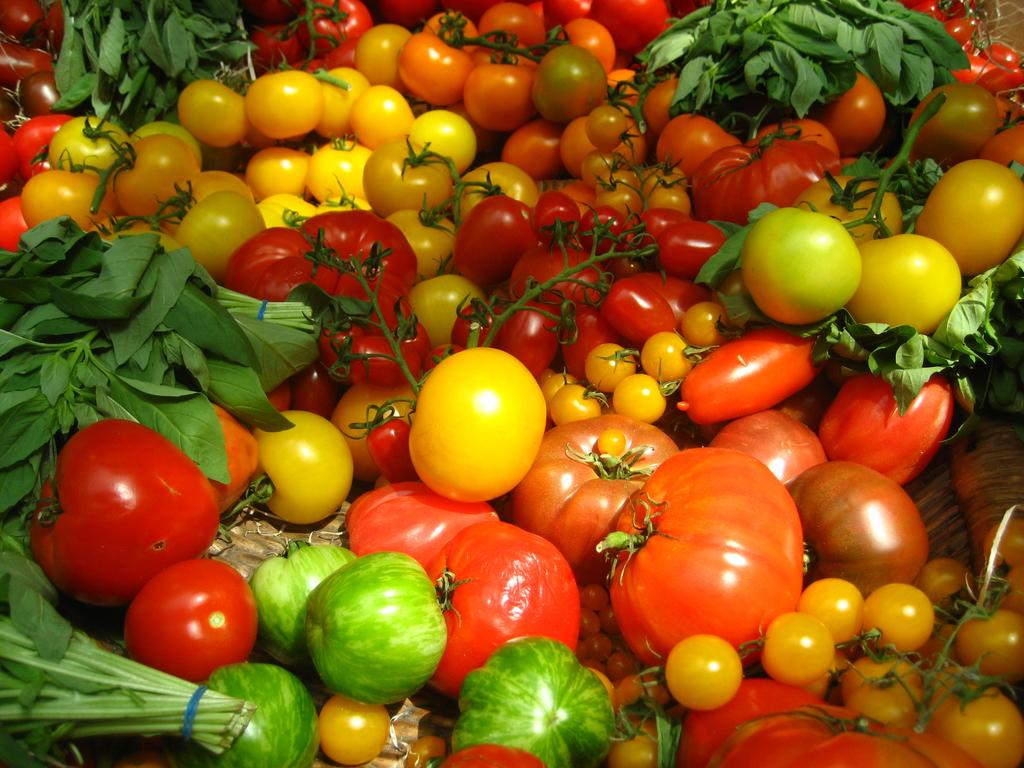What type of food items can be seen in the image? There are vegetables visible in the image. Can you tell me how many jellyfish are swimming in the vegetables in the image? There are no jellyfish present in the image, as it features vegetables. What type of butter is being used to cook the vegetables in the image? There is no butter present in the image, as it only features vegetables. 